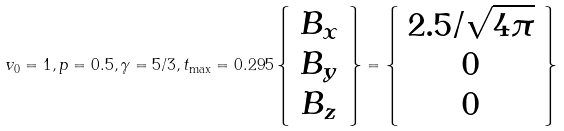Convert formula to latex. <formula><loc_0><loc_0><loc_500><loc_500>v _ { 0 } = 1 , p = 0 . 5 , \gamma = 5 / 3 , t _ { \max } = 0 . 2 9 5 \left \{ \begin{array} { c } B _ { x } \\ B _ { y } \\ B _ { z } \end{array} \right \} = \left \{ \begin{array} { c } 2 . 5 / \sqrt { 4 \pi } \\ 0 \\ 0 \end{array} \right \}</formula> 